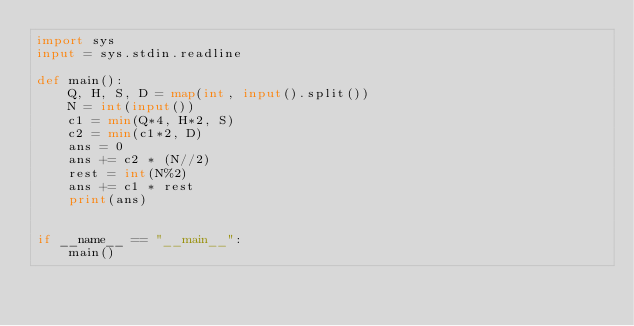Convert code to text. <code><loc_0><loc_0><loc_500><loc_500><_Python_>import sys
input = sys.stdin.readline

def main():
    Q, H, S, D = map(int, input().split())
    N = int(input())
    c1 = min(Q*4, H*2, S)
    c2 = min(c1*2, D)
    ans = 0
    ans += c2 * (N//2)
    rest = int(N%2)
    ans += c1 * rest
    print(ans)


if __name__ == "__main__":
    main()</code> 